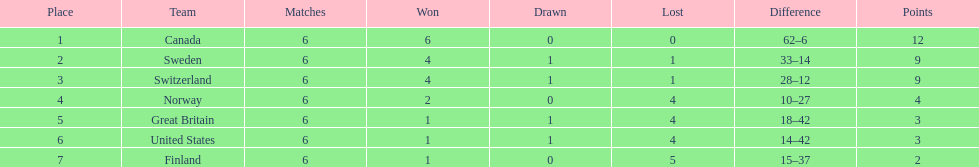What was the sum of points achieved by great britain? 3. 